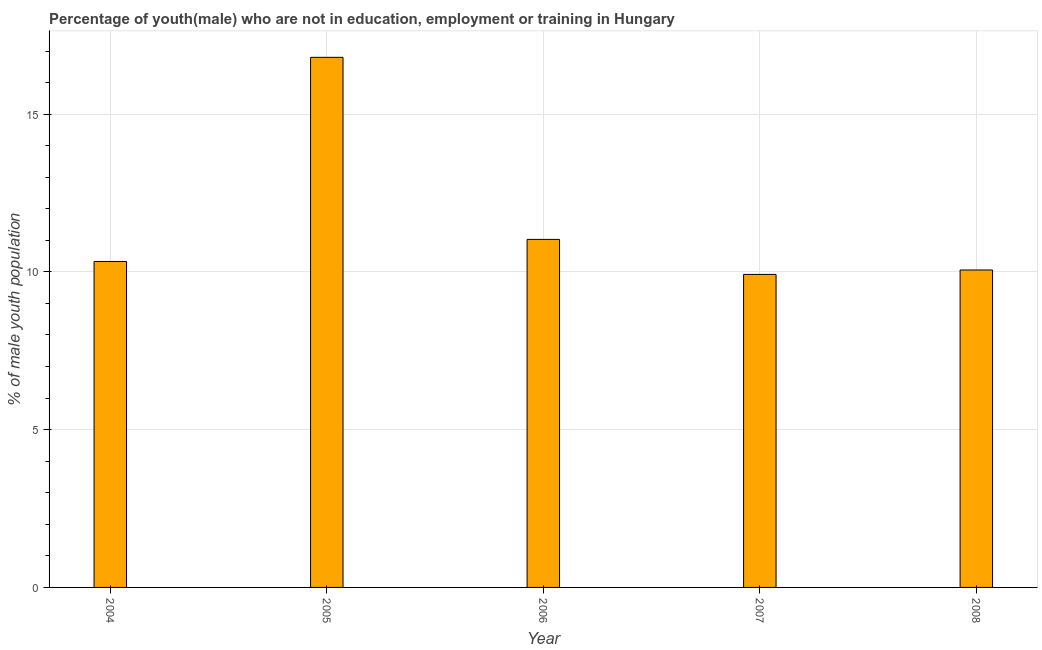What is the title of the graph?
Provide a short and direct response. Percentage of youth(male) who are not in education, employment or training in Hungary. What is the label or title of the Y-axis?
Provide a succinct answer. % of male youth population. What is the unemployed male youth population in 2005?
Your answer should be compact. 16.8. Across all years, what is the maximum unemployed male youth population?
Ensure brevity in your answer.  16.8. Across all years, what is the minimum unemployed male youth population?
Your answer should be compact. 9.92. In which year was the unemployed male youth population minimum?
Your answer should be compact. 2007. What is the sum of the unemployed male youth population?
Offer a terse response. 58.14. What is the difference between the unemployed male youth population in 2007 and 2008?
Your response must be concise. -0.14. What is the average unemployed male youth population per year?
Give a very brief answer. 11.63. What is the median unemployed male youth population?
Make the answer very short. 10.33. In how many years, is the unemployed male youth population greater than 8 %?
Your answer should be compact. 5. Do a majority of the years between 2004 and 2005 (inclusive) have unemployed male youth population greater than 15 %?
Your response must be concise. No. What is the ratio of the unemployed male youth population in 2004 to that in 2008?
Provide a short and direct response. 1.03. What is the difference between the highest and the second highest unemployed male youth population?
Offer a terse response. 5.77. Is the sum of the unemployed male youth population in 2005 and 2007 greater than the maximum unemployed male youth population across all years?
Provide a succinct answer. Yes. What is the difference between the highest and the lowest unemployed male youth population?
Give a very brief answer. 6.88. How many bars are there?
Give a very brief answer. 5. How many years are there in the graph?
Keep it short and to the point. 5. What is the difference between two consecutive major ticks on the Y-axis?
Keep it short and to the point. 5. Are the values on the major ticks of Y-axis written in scientific E-notation?
Keep it short and to the point. No. What is the % of male youth population in 2004?
Keep it short and to the point. 10.33. What is the % of male youth population in 2005?
Ensure brevity in your answer.  16.8. What is the % of male youth population of 2006?
Keep it short and to the point. 11.03. What is the % of male youth population in 2007?
Your response must be concise. 9.92. What is the % of male youth population of 2008?
Your response must be concise. 10.06. What is the difference between the % of male youth population in 2004 and 2005?
Your response must be concise. -6.47. What is the difference between the % of male youth population in 2004 and 2007?
Your response must be concise. 0.41. What is the difference between the % of male youth population in 2004 and 2008?
Your response must be concise. 0.27. What is the difference between the % of male youth population in 2005 and 2006?
Your response must be concise. 5.77. What is the difference between the % of male youth population in 2005 and 2007?
Your answer should be compact. 6.88. What is the difference between the % of male youth population in 2005 and 2008?
Offer a terse response. 6.74. What is the difference between the % of male youth population in 2006 and 2007?
Provide a succinct answer. 1.11. What is the difference between the % of male youth population in 2006 and 2008?
Your answer should be compact. 0.97. What is the difference between the % of male youth population in 2007 and 2008?
Give a very brief answer. -0.14. What is the ratio of the % of male youth population in 2004 to that in 2005?
Your answer should be compact. 0.61. What is the ratio of the % of male youth population in 2004 to that in 2006?
Offer a very short reply. 0.94. What is the ratio of the % of male youth population in 2004 to that in 2007?
Make the answer very short. 1.04. What is the ratio of the % of male youth population in 2005 to that in 2006?
Your response must be concise. 1.52. What is the ratio of the % of male youth population in 2005 to that in 2007?
Offer a terse response. 1.69. What is the ratio of the % of male youth population in 2005 to that in 2008?
Your response must be concise. 1.67. What is the ratio of the % of male youth population in 2006 to that in 2007?
Your answer should be compact. 1.11. What is the ratio of the % of male youth population in 2006 to that in 2008?
Make the answer very short. 1.1. What is the ratio of the % of male youth population in 2007 to that in 2008?
Ensure brevity in your answer.  0.99. 